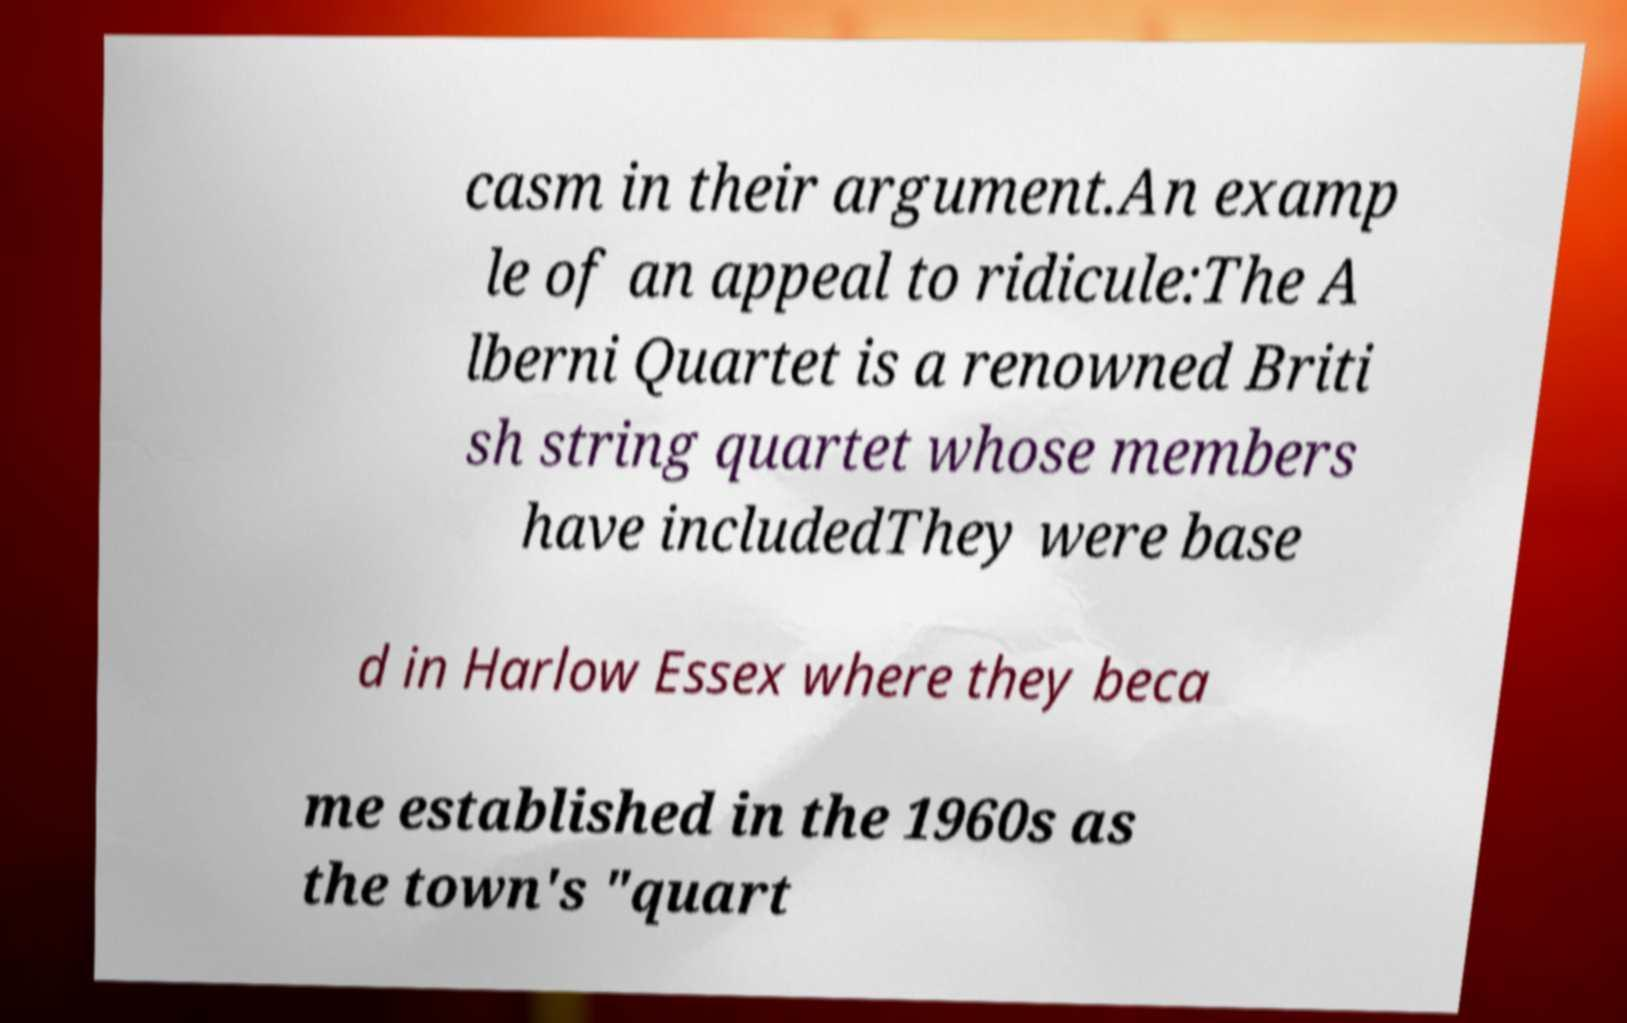Please identify and transcribe the text found in this image. casm in their argument.An examp le of an appeal to ridicule:The A lberni Quartet is a renowned Briti sh string quartet whose members have includedThey were base d in Harlow Essex where they beca me established in the 1960s as the town's "quart 